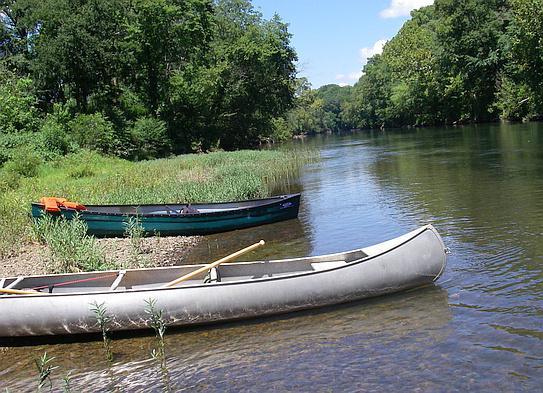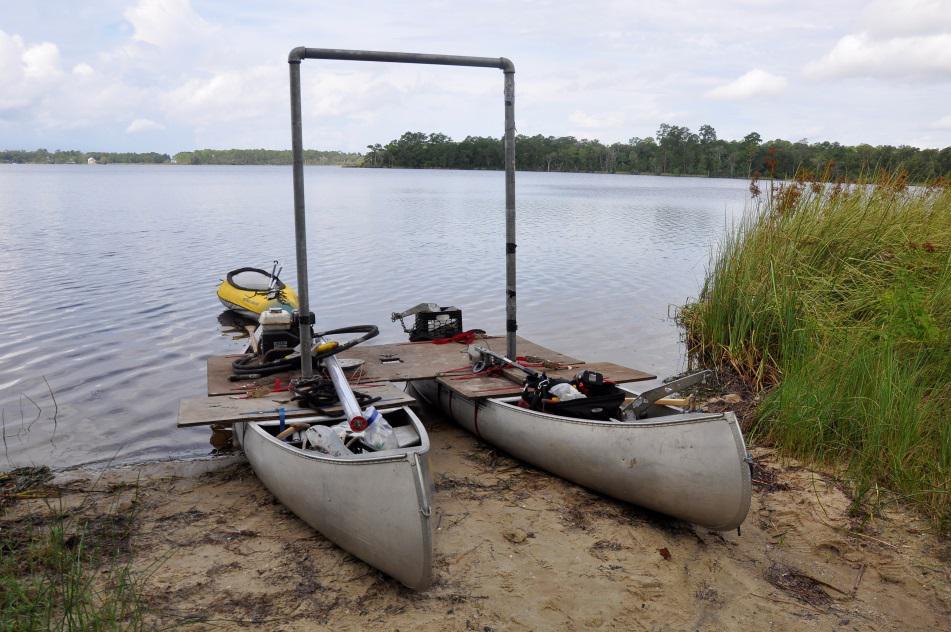The first image is the image on the left, the second image is the image on the right. Assess this claim about the two images: "At least one image shows watercraft that is pulled up to the edge of the water.". Correct or not? Answer yes or no. Yes. The first image is the image on the left, the second image is the image on the right. Evaluate the accuracy of this statement regarding the images: "There are canoes sitting on the beach". Is it true? Answer yes or no. Yes. 